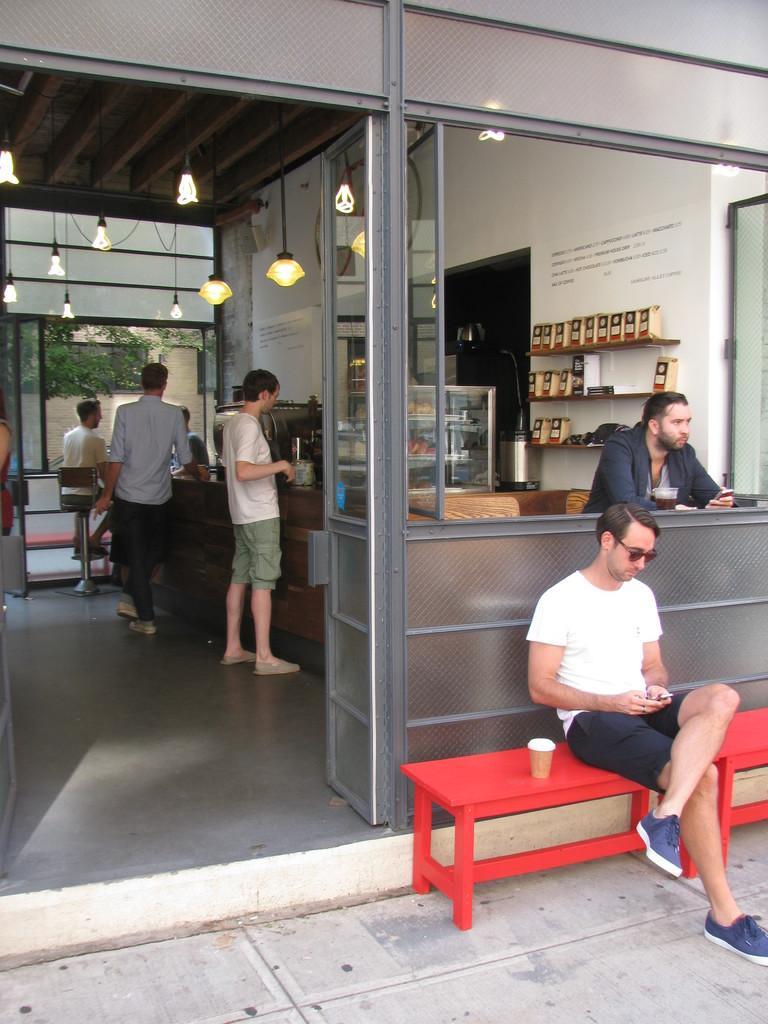In one or two sentences, can you explain what this image depicts? In this picture we can see a man who is sitting on the bench. This is floor. Here we can see some persons are standing on the floor. These are the lights and there is a wall. 